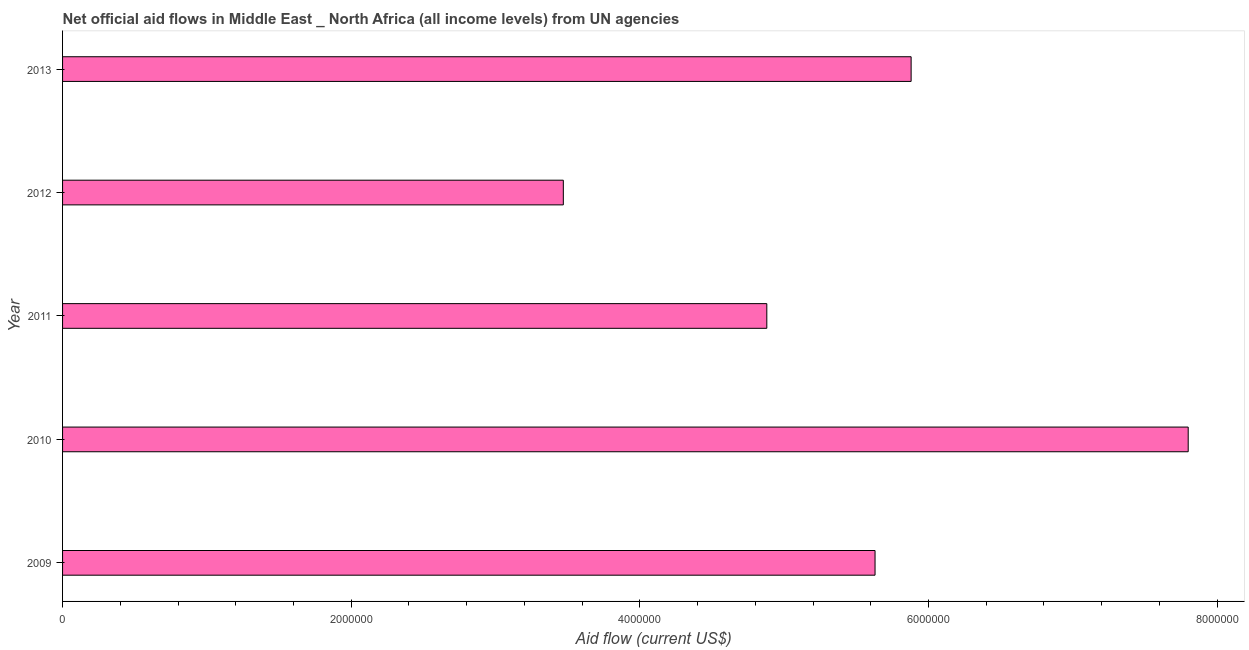Does the graph contain any zero values?
Your response must be concise. No. Does the graph contain grids?
Provide a succinct answer. No. What is the title of the graph?
Ensure brevity in your answer.  Net official aid flows in Middle East _ North Africa (all income levels) from UN agencies. What is the label or title of the X-axis?
Make the answer very short. Aid flow (current US$). What is the net official flows from un agencies in 2012?
Make the answer very short. 3.47e+06. Across all years, what is the maximum net official flows from un agencies?
Provide a succinct answer. 7.80e+06. Across all years, what is the minimum net official flows from un agencies?
Your answer should be very brief. 3.47e+06. In which year was the net official flows from un agencies minimum?
Keep it short and to the point. 2012. What is the sum of the net official flows from un agencies?
Offer a terse response. 2.77e+07. What is the average net official flows from un agencies per year?
Ensure brevity in your answer.  5.53e+06. What is the median net official flows from un agencies?
Ensure brevity in your answer.  5.63e+06. In how many years, is the net official flows from un agencies greater than 4400000 US$?
Give a very brief answer. 4. What is the ratio of the net official flows from un agencies in 2011 to that in 2013?
Offer a terse response. 0.83. Is the net official flows from un agencies in 2010 less than that in 2011?
Provide a short and direct response. No. Is the difference between the net official flows from un agencies in 2010 and 2013 greater than the difference between any two years?
Offer a very short reply. No. What is the difference between the highest and the second highest net official flows from un agencies?
Offer a terse response. 1.92e+06. Is the sum of the net official flows from un agencies in 2012 and 2013 greater than the maximum net official flows from un agencies across all years?
Your answer should be compact. Yes. What is the difference between the highest and the lowest net official flows from un agencies?
Your answer should be compact. 4.33e+06. In how many years, is the net official flows from un agencies greater than the average net official flows from un agencies taken over all years?
Ensure brevity in your answer.  3. How many bars are there?
Your answer should be very brief. 5. What is the difference between two consecutive major ticks on the X-axis?
Make the answer very short. 2.00e+06. What is the Aid flow (current US$) of 2009?
Provide a short and direct response. 5.63e+06. What is the Aid flow (current US$) in 2010?
Keep it short and to the point. 7.80e+06. What is the Aid flow (current US$) in 2011?
Provide a short and direct response. 4.88e+06. What is the Aid flow (current US$) in 2012?
Your response must be concise. 3.47e+06. What is the Aid flow (current US$) of 2013?
Your answer should be compact. 5.88e+06. What is the difference between the Aid flow (current US$) in 2009 and 2010?
Provide a succinct answer. -2.17e+06. What is the difference between the Aid flow (current US$) in 2009 and 2011?
Give a very brief answer. 7.50e+05. What is the difference between the Aid flow (current US$) in 2009 and 2012?
Keep it short and to the point. 2.16e+06. What is the difference between the Aid flow (current US$) in 2010 and 2011?
Your answer should be very brief. 2.92e+06. What is the difference between the Aid flow (current US$) in 2010 and 2012?
Give a very brief answer. 4.33e+06. What is the difference between the Aid flow (current US$) in 2010 and 2013?
Provide a succinct answer. 1.92e+06. What is the difference between the Aid flow (current US$) in 2011 and 2012?
Offer a very short reply. 1.41e+06. What is the difference between the Aid flow (current US$) in 2011 and 2013?
Make the answer very short. -1.00e+06. What is the difference between the Aid flow (current US$) in 2012 and 2013?
Give a very brief answer. -2.41e+06. What is the ratio of the Aid flow (current US$) in 2009 to that in 2010?
Make the answer very short. 0.72. What is the ratio of the Aid flow (current US$) in 2009 to that in 2011?
Your answer should be very brief. 1.15. What is the ratio of the Aid flow (current US$) in 2009 to that in 2012?
Provide a short and direct response. 1.62. What is the ratio of the Aid flow (current US$) in 2010 to that in 2011?
Provide a succinct answer. 1.6. What is the ratio of the Aid flow (current US$) in 2010 to that in 2012?
Your answer should be very brief. 2.25. What is the ratio of the Aid flow (current US$) in 2010 to that in 2013?
Provide a short and direct response. 1.33. What is the ratio of the Aid flow (current US$) in 2011 to that in 2012?
Give a very brief answer. 1.41. What is the ratio of the Aid flow (current US$) in 2011 to that in 2013?
Your answer should be very brief. 0.83. What is the ratio of the Aid flow (current US$) in 2012 to that in 2013?
Offer a terse response. 0.59. 